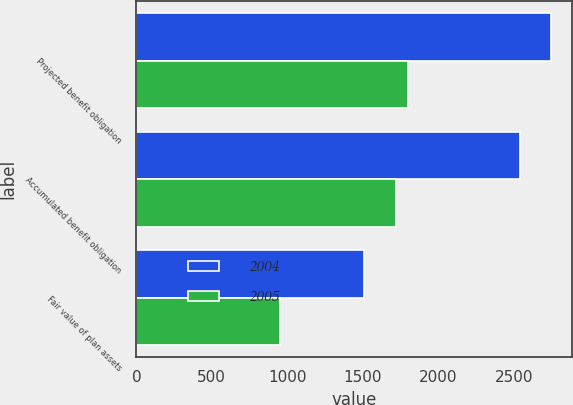Convert chart to OTSL. <chart><loc_0><loc_0><loc_500><loc_500><stacked_bar_chart><ecel><fcel>Projected benefit obligation<fcel>Accumulated benefit obligation<fcel>Fair value of plan assets<nl><fcel>2004<fcel>2746<fcel>2541<fcel>1511<nl><fcel>2005<fcel>1801<fcel>1720<fcel>950<nl></chart> 